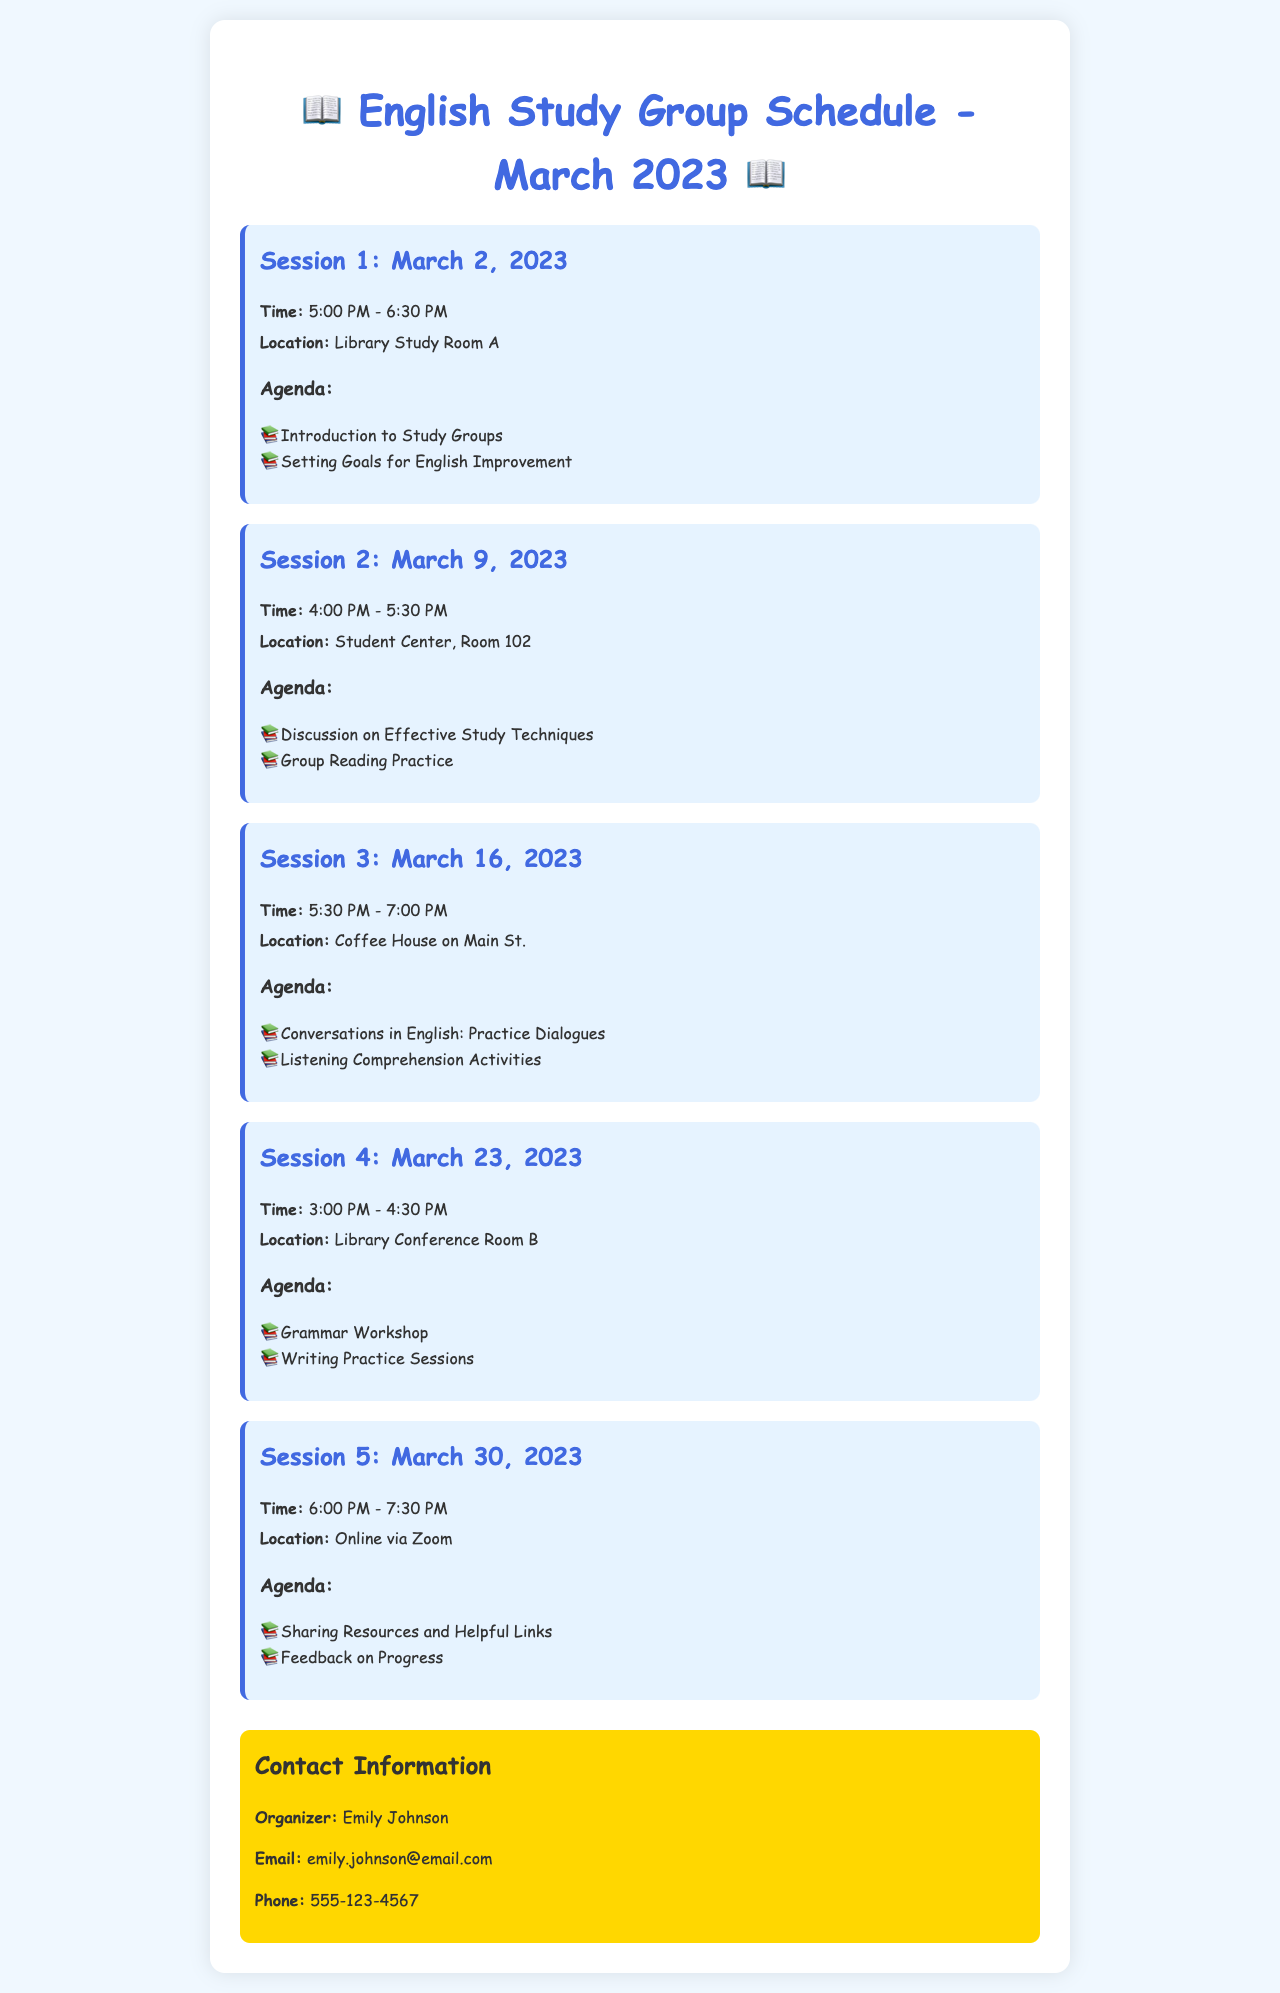What is the first session date? The first session is scheduled for March 2, 2023, as stated in the document.
Answer: March 2, 2023 What time does the second session start? The start time for the second session is provided in the document as 4:00 PM.
Answer: 4:00 PM Where is Session 3 held? The location for Session 3 is mentioned in the document as the Coffee House on Main St.
Answer: Coffee House on Main St How many sessions are held in March 2023? The document lists a total of five sessions for the month.
Answer: Five What is the agenda item for the last session? The last session's agenda includes sharing resources and feedback on progress, as outlined in the document.
Answer: Sharing Resources and Helpful Links What is the location of Session 4? The document states that Session 4 takes place in Library Conference Room B.
Answer: Library Conference Room B Who is the organizer of the study group? The document specifies Emily Johnson as the organizer of the study group.
Answer: Emily Johnson What type of meeting is Session 5? The document indicates that Session 5 is an online meeting via Zoom.
Answer: Online via Zoom 